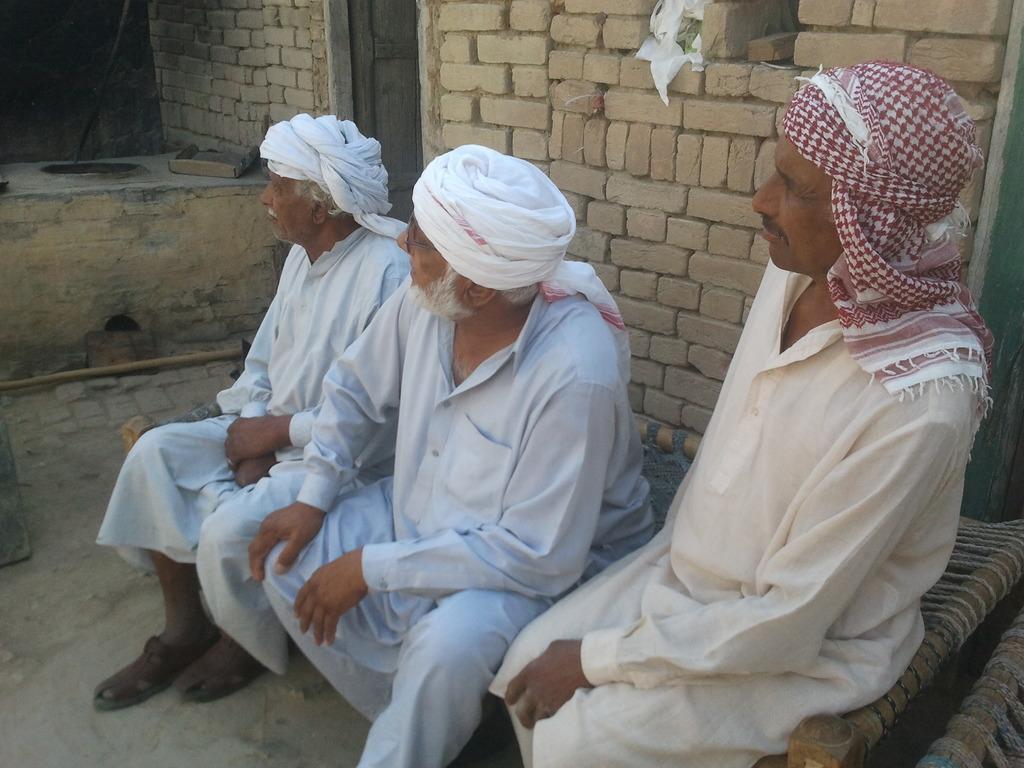Please provide a concise description of this image. In the center of the image there are there persons sitting on a cot wearing turbans. In the background of the image there is wall. 